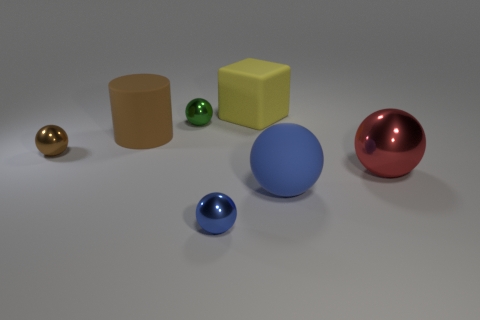There is a tiny object that is in front of the brown metal ball; what color is it?
Your response must be concise. Blue. There is a sphere that is made of the same material as the cylinder; what is its size?
Your answer should be very brief. Large. How many large blue rubber objects are the same shape as the tiny blue thing?
Ensure brevity in your answer.  1. There is a red sphere that is the same size as the yellow object; what is its material?
Make the answer very short. Metal. Is there a large gray ball made of the same material as the big brown cylinder?
Provide a succinct answer. No. The object that is to the left of the yellow matte block and in front of the red thing is what color?
Make the answer very short. Blue. What number of other things are there of the same color as the big metallic ball?
Give a very brief answer. 0. What material is the small brown thing left of the tiny shiny sphere behind the large matte thing that is on the left side of the small blue ball?
Offer a very short reply. Metal. What number of cylinders are either big objects or large red objects?
Your answer should be compact. 1. What number of large cubes are in front of the matte object that is in front of the shiny thing on the right side of the yellow rubber cube?
Make the answer very short. 0. 